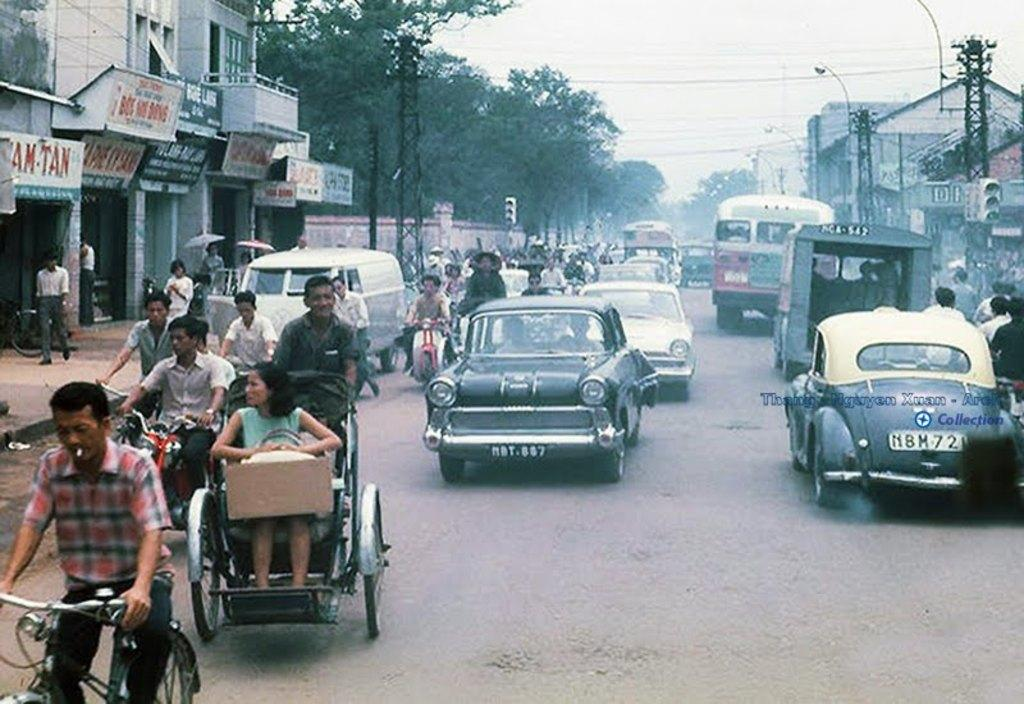What are the people in the image doing? The people are riding a bicycle, a motorcycle, cars, and a lorry in the image. What can be seen in the background of the image? There are trees, the sky, shops, and a pole visible in the background of the image. What type of soap is being used by the children in the image? There are no children or soap present in the image. 